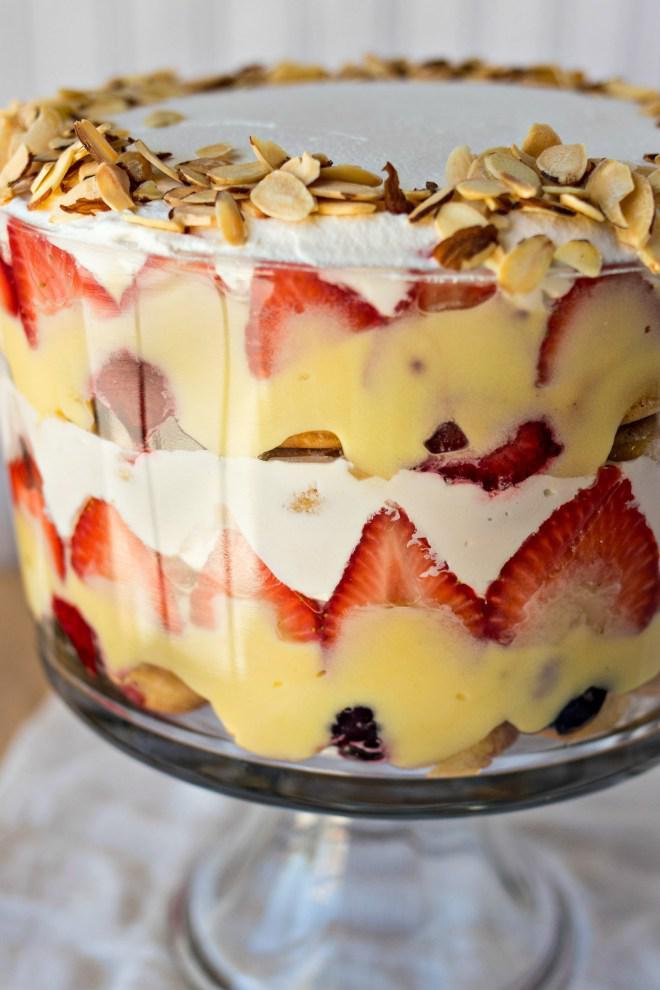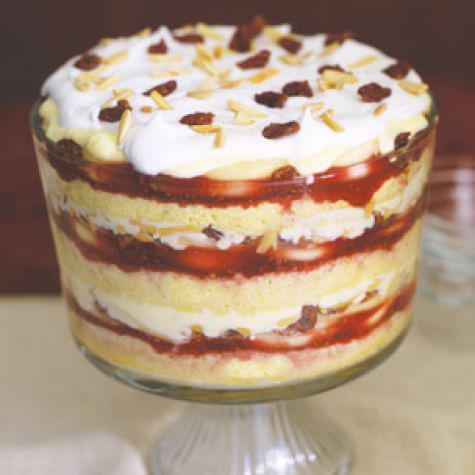The first image is the image on the left, the second image is the image on the right. Given the left and right images, does the statement "Two large trifle desserts are made in clear footed bowls with alernating creamy layers and red fruit." hold true? Answer yes or no. Yes. The first image is the image on the left, the second image is the image on the right. Evaluate the accuracy of this statement regarding the images: "An image shows a dessert with garnish that includes red berries and a green leaf.". Is it true? Answer yes or no. No. 